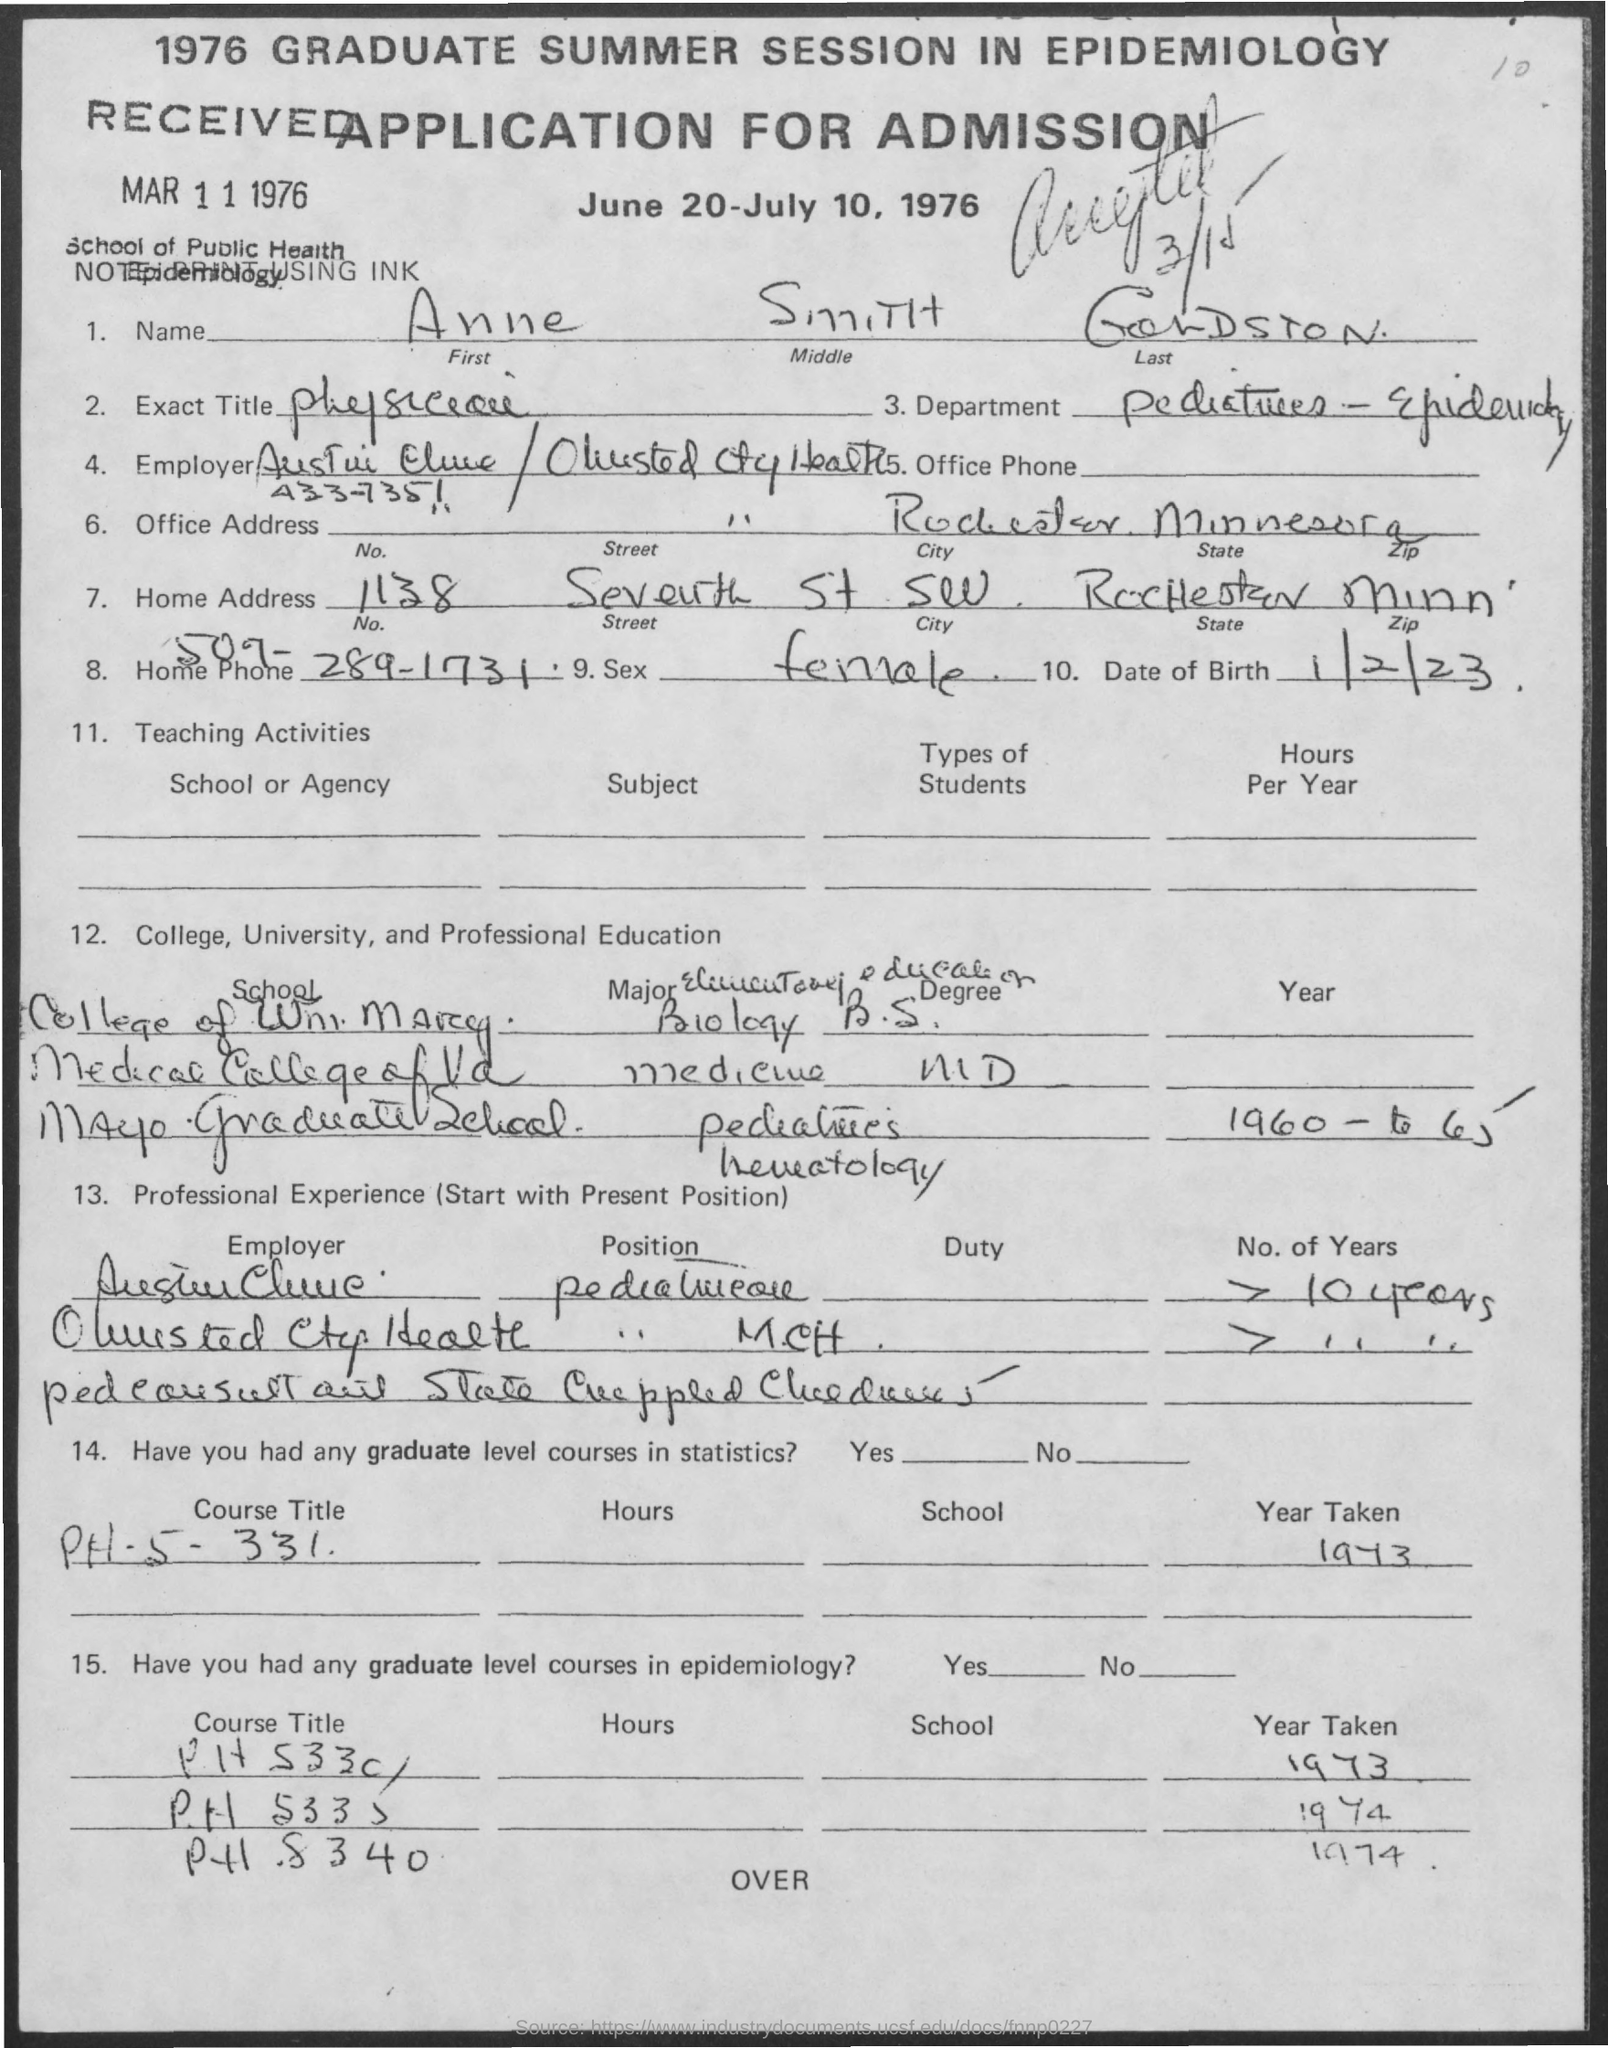Highlight a few significant elements in this photo. The applicant's date of birth is January 2, 1923. What is the exact title of the Physician Executive role at Envision Healthcare? 